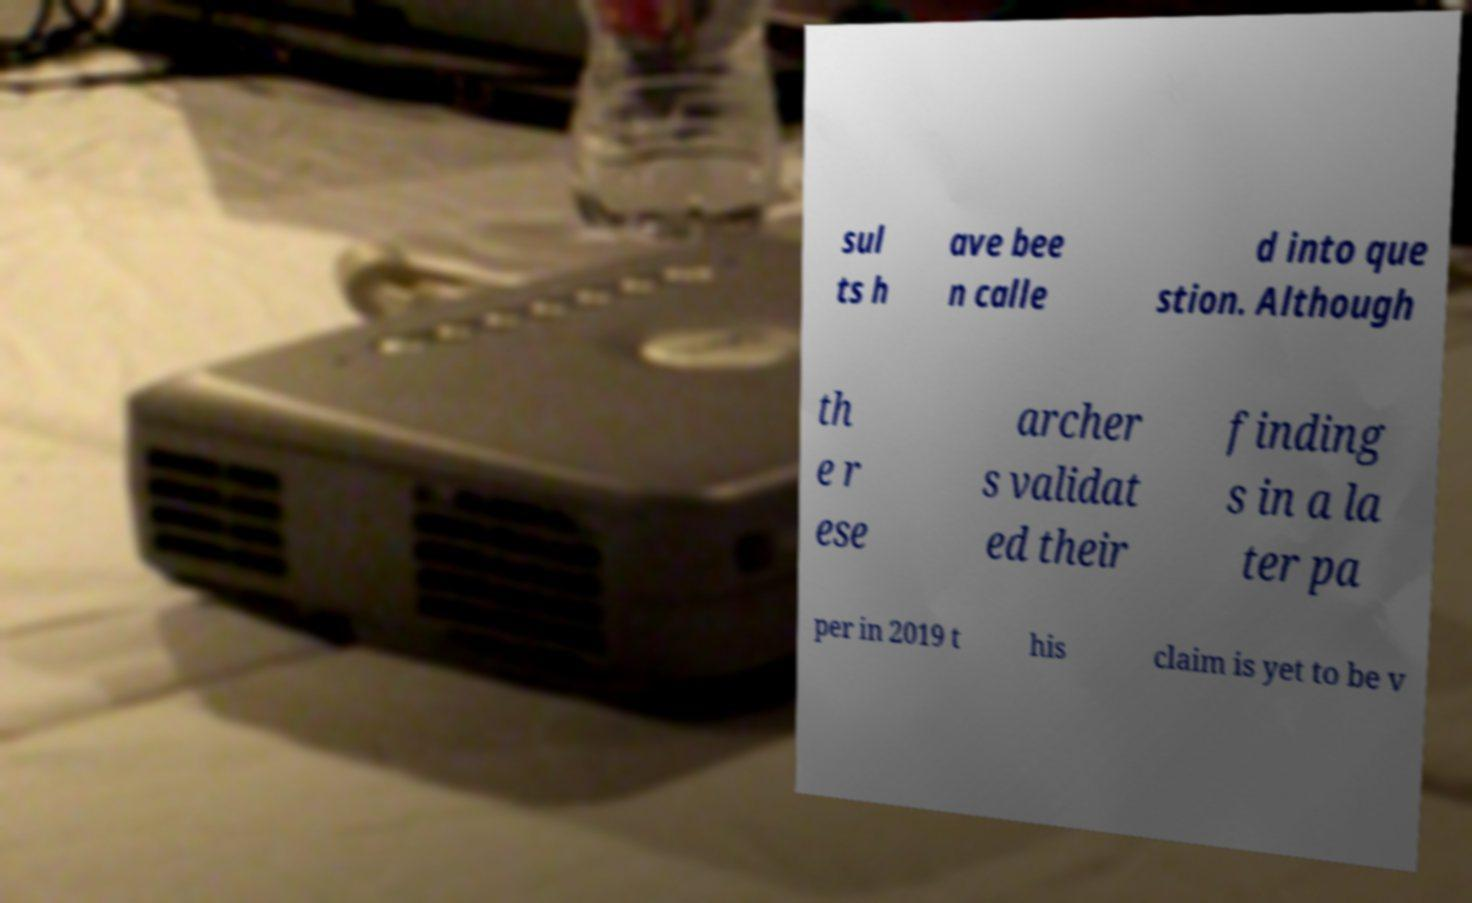Can you read and provide the text displayed in the image?This photo seems to have some interesting text. Can you extract and type it out for me? sul ts h ave bee n calle d into que stion. Although th e r ese archer s validat ed their finding s in a la ter pa per in 2019 t his claim is yet to be v 